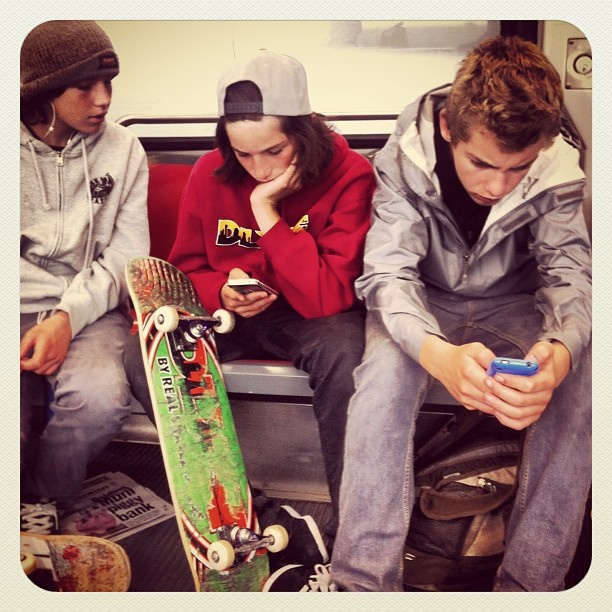Describe the objects in this image and their specific colors. I can see people in ivory, gray, brown, darkgray, and tan tones, people in ivory, maroon, brown, and black tones, people in ivory, black, tan, maroon, and brown tones, skateboard in ivory, olive, tan, maroon, and brown tones, and backpack in ivory, black, maroon, and brown tones in this image. 